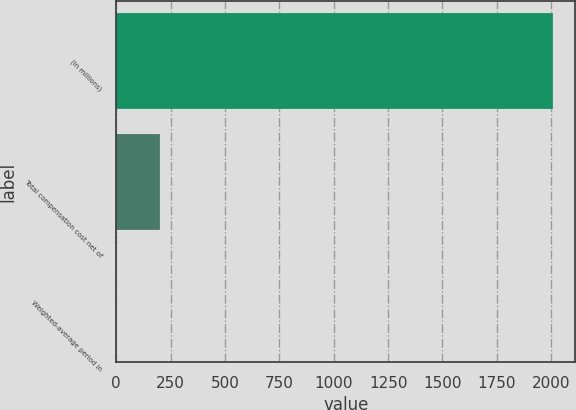<chart> <loc_0><loc_0><loc_500><loc_500><bar_chart><fcel>(in millions)<fcel>Total compensation cost net of<fcel>Weighted-average period in<nl><fcel>2010<fcel>202.62<fcel>1.8<nl></chart> 